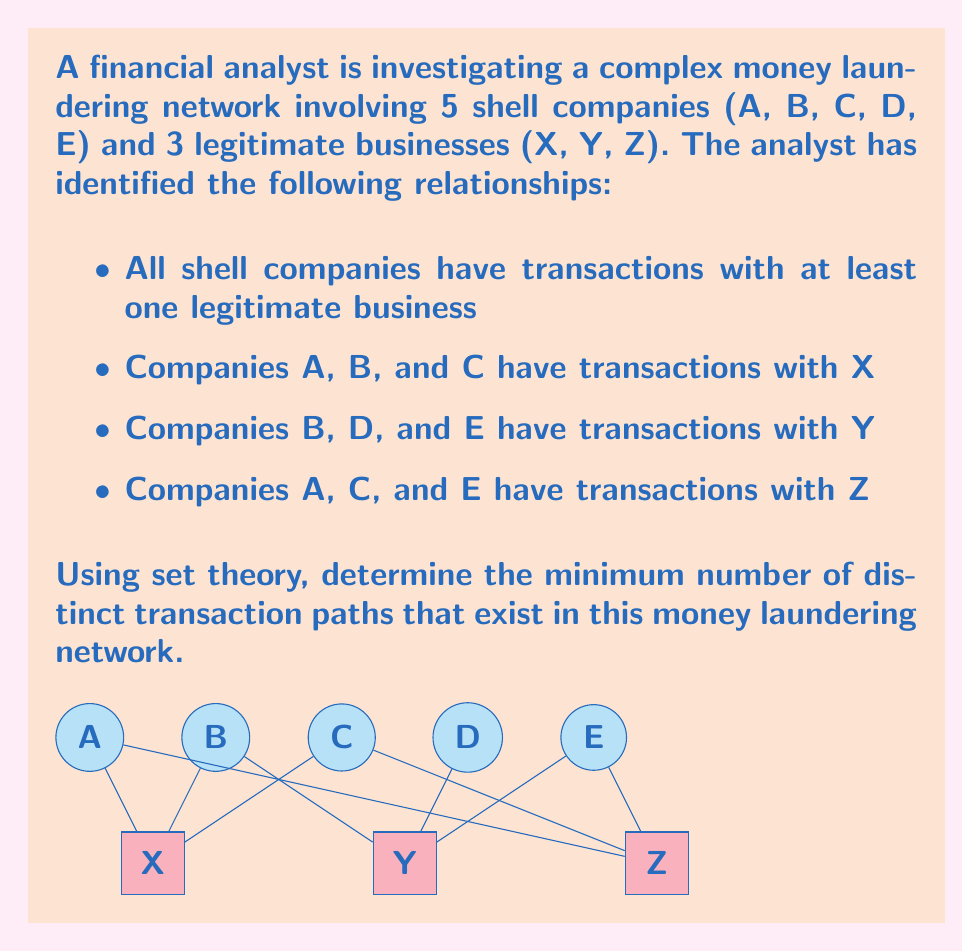Solve this math problem. To solve this problem, we'll use set theory to analyze the transaction paths:

1) Let's define sets for each legitimate business:
   $X = \{A, B, C\}$
   $Y = \{B, D, E\}$
   $Z = \{A, C, E\}$

2) The total number of transaction paths is the sum of the cardinalities of these sets:
   $|X| + |Y| + |Z| = 3 + 3 + 3 = 9$

3) However, this count includes duplicates. To find the minimum number of distinct paths, we need to find the cardinality of the union of these sets:
   $|X \cup Y \cup Z|$

4) We can use the Inclusion-Exclusion Principle:
   $|X \cup Y \cup Z| = |X| + |Y| + |Z| - |X \cap Y| - |Y \cap Z| - |X \cap Z| + |X \cap Y \cap Z|$

5) Let's calculate the intersections:
   $X \cap Y = \{B\}$, so $|X \cap Y| = 1$
   $Y \cap Z = \{E\}$, so $|Y \cap Z| = 1$
   $X \cap Z = \{A, C\}$, so $|X \cap Z| = 2$
   $X \cap Y \cap Z = \emptyset$, so $|X \cap Y \cap Z| = 0$

6) Now we can substitute these values:
   $|X \cup Y \cup Z| = 3 + 3 + 3 - 1 - 1 - 2 + 0 = 5$

Therefore, there are 5 distinct transaction paths in this money laundering network.
Answer: 5 distinct transaction paths 